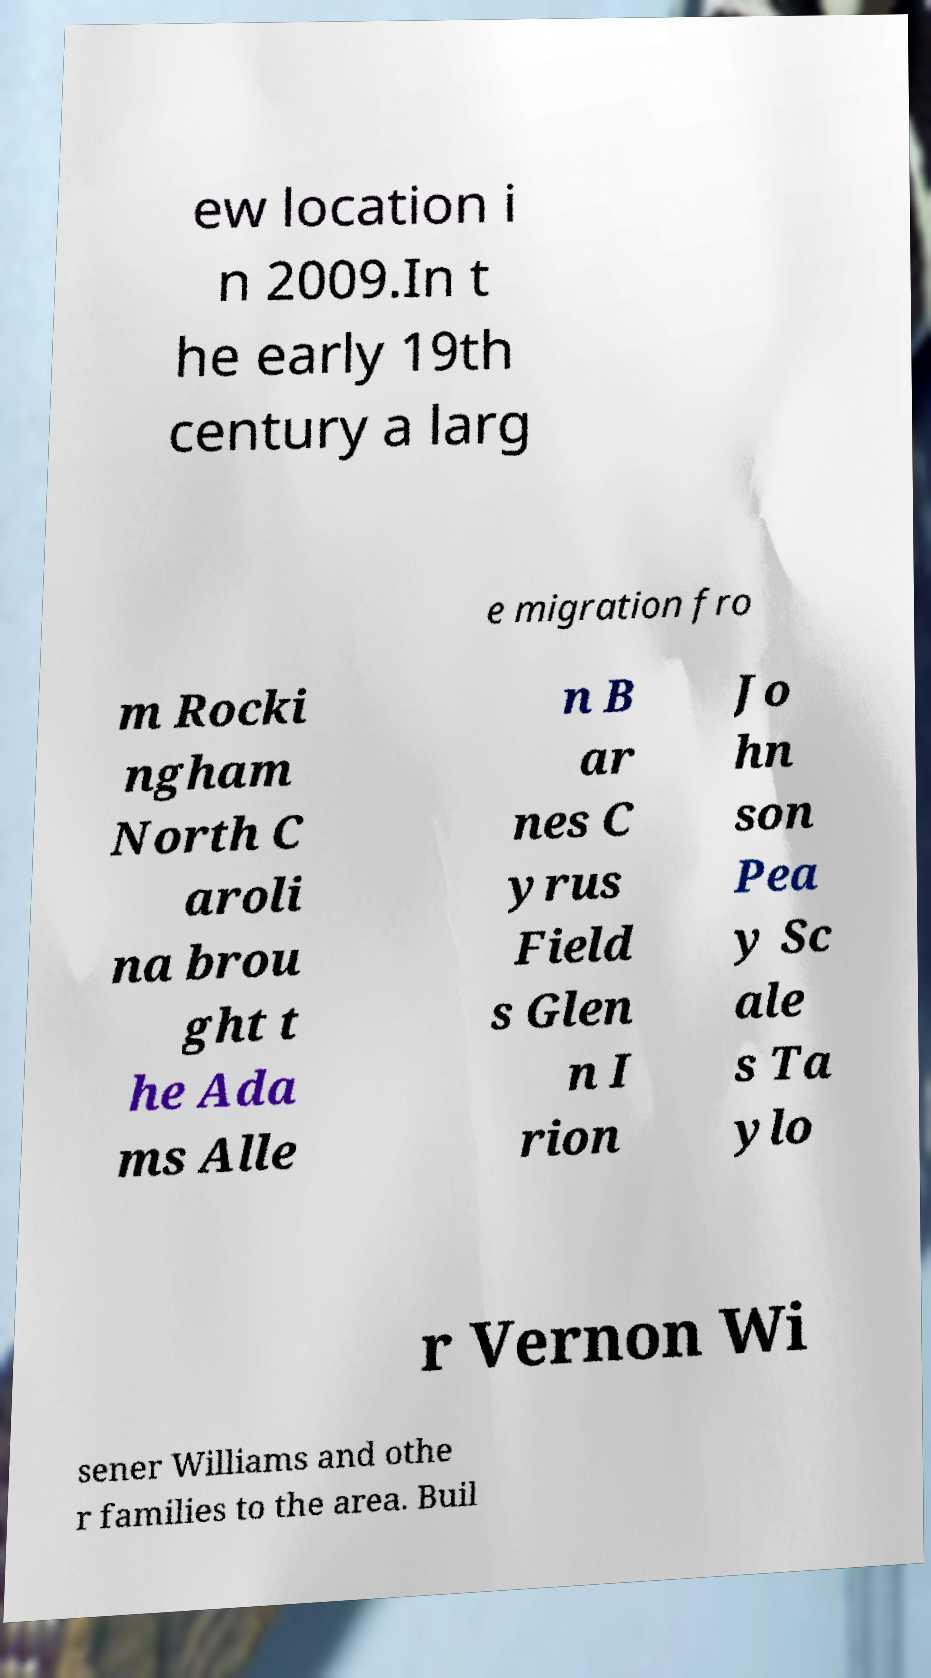There's text embedded in this image that I need extracted. Can you transcribe it verbatim? ew location i n 2009.In t he early 19th century a larg e migration fro m Rocki ngham North C aroli na brou ght t he Ada ms Alle n B ar nes C yrus Field s Glen n I rion Jo hn son Pea y Sc ale s Ta ylo r Vernon Wi sener Williams and othe r families to the area. Buil 